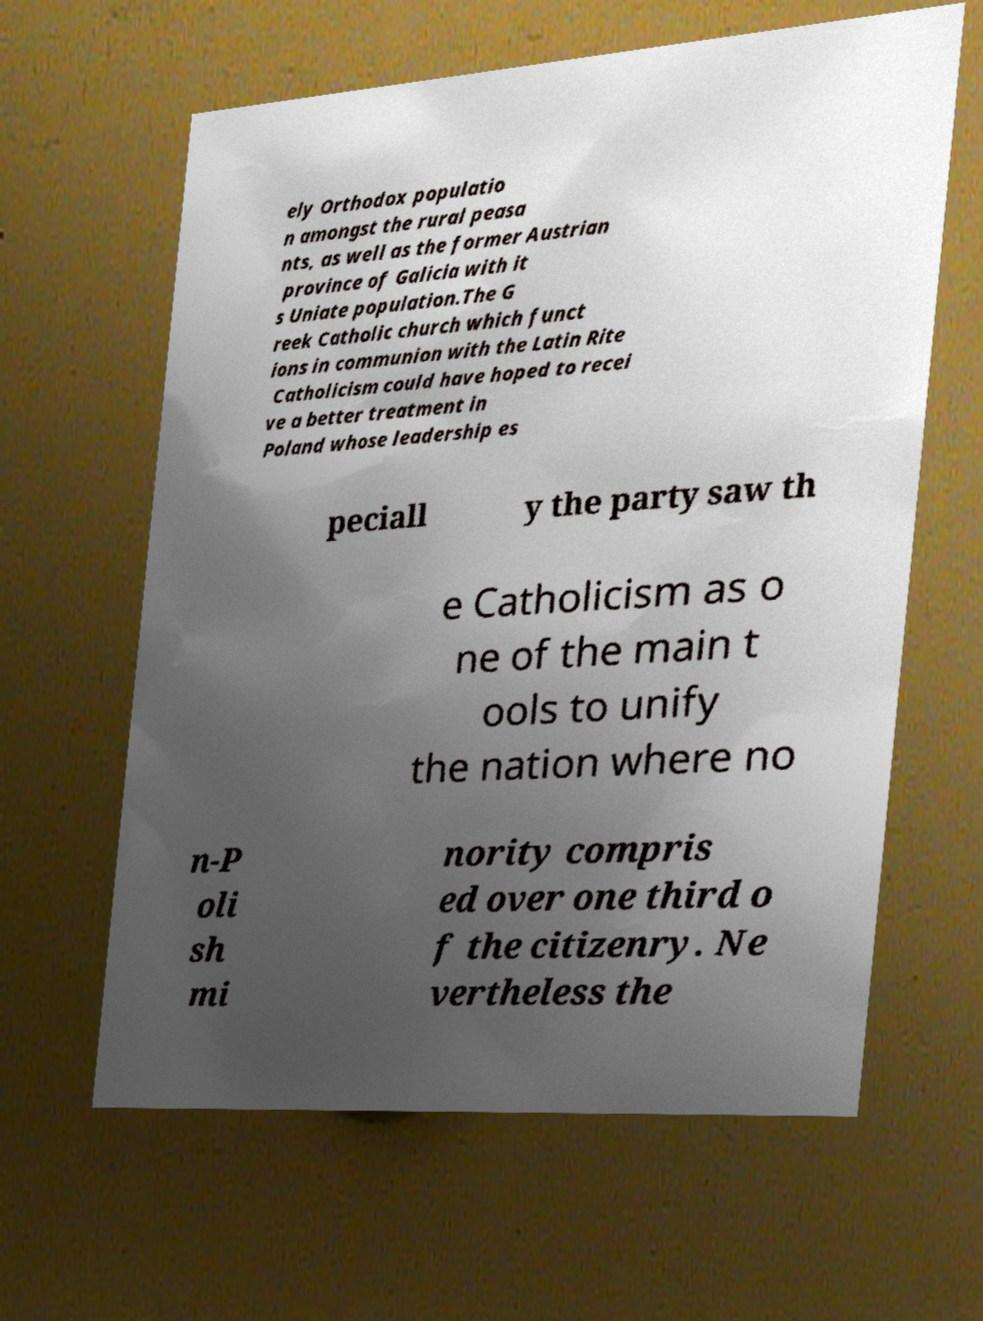Please read and relay the text visible in this image. What does it say? ely Orthodox populatio n amongst the rural peasa nts, as well as the former Austrian province of Galicia with it s Uniate population.The G reek Catholic church which funct ions in communion with the Latin Rite Catholicism could have hoped to recei ve a better treatment in Poland whose leadership es peciall y the party saw th e Catholicism as o ne of the main t ools to unify the nation where no n-P oli sh mi nority compris ed over one third o f the citizenry. Ne vertheless the 